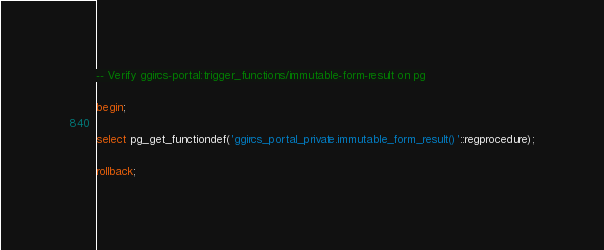Convert code to text. <code><loc_0><loc_0><loc_500><loc_500><_SQL_>-- Verify ggircs-portal:trigger_functions/immutable-form-result on pg

begin;

select pg_get_functiondef('ggircs_portal_private.immutable_form_result()'::regprocedure);

rollback;
</code> 